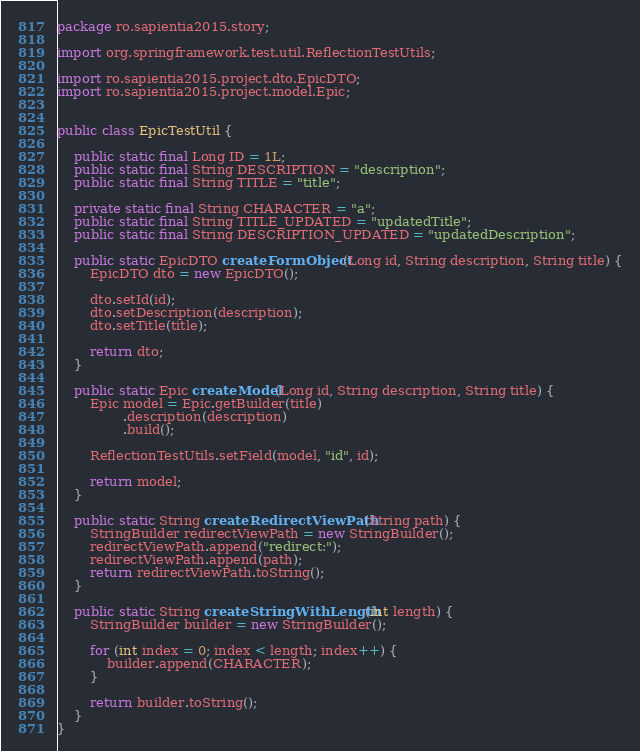Convert code to text. <code><loc_0><loc_0><loc_500><loc_500><_Java_>package ro.sapientia2015.story;

import org.springframework.test.util.ReflectionTestUtils;

import ro.sapientia2015.project.dto.EpicDTO;
import ro.sapientia2015.project.model.Epic;


public class EpicTestUtil {

    public static final Long ID = 1L;
    public static final String DESCRIPTION = "description";
    public static final String TITLE = "title";

    private static final String CHARACTER = "a";
	public static final String TITLE_UPDATED = "updatedTitle";
	public static final String DESCRIPTION_UPDATED = "updatedDescription";

    public static EpicDTO createFormObject(Long id, String description, String title) {
    	EpicDTO dto = new EpicDTO();

        dto.setId(id);
        dto.setDescription(description);
        dto.setTitle(title);

        return dto;
    }

    public static Epic createModel(Long id, String description, String title) {
    	Epic model = Epic.getBuilder(title)
                .description(description)
                .build();

        ReflectionTestUtils.setField(model, "id", id);

        return model;
    }

    public static String createRedirectViewPath(String path) {
        StringBuilder redirectViewPath = new StringBuilder();
        redirectViewPath.append("redirect:");
        redirectViewPath.append(path);
        return redirectViewPath.toString();
    }

    public static String createStringWithLength(int length) {
        StringBuilder builder = new StringBuilder();

        for (int index = 0; index < length; index++) {
            builder.append(CHARACTER);
        }

        return builder.toString();
    }
}
</code> 